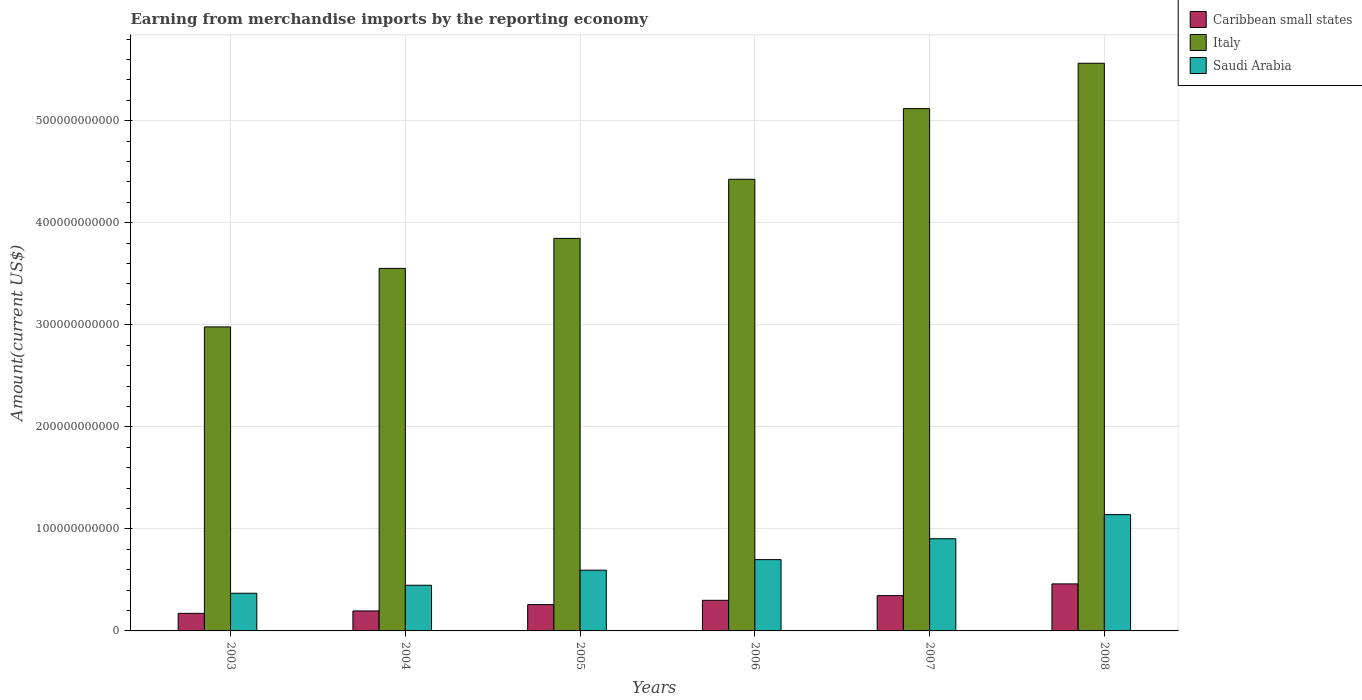How many different coloured bars are there?
Ensure brevity in your answer.  3. Are the number of bars per tick equal to the number of legend labels?
Make the answer very short. Yes. How many bars are there on the 1st tick from the right?
Your answer should be compact. 3. What is the amount earned from merchandise imports in Saudi Arabia in 2004?
Provide a short and direct response. 4.47e+1. Across all years, what is the maximum amount earned from merchandise imports in Caribbean small states?
Provide a succinct answer. 4.61e+1. Across all years, what is the minimum amount earned from merchandise imports in Caribbean small states?
Provide a short and direct response. 1.72e+1. In which year was the amount earned from merchandise imports in Saudi Arabia maximum?
Offer a very short reply. 2008. In which year was the amount earned from merchandise imports in Italy minimum?
Give a very brief answer. 2003. What is the total amount earned from merchandise imports in Saudi Arabia in the graph?
Offer a terse response. 4.15e+11. What is the difference between the amount earned from merchandise imports in Caribbean small states in 2004 and that in 2007?
Your answer should be compact. -1.50e+1. What is the difference between the amount earned from merchandise imports in Saudi Arabia in 2007 and the amount earned from merchandise imports in Caribbean small states in 2006?
Your answer should be very brief. 6.04e+1. What is the average amount earned from merchandise imports in Saudi Arabia per year?
Offer a very short reply. 6.92e+1. In the year 2003, what is the difference between the amount earned from merchandise imports in Saudi Arabia and amount earned from merchandise imports in Italy?
Offer a very short reply. -2.61e+11. What is the ratio of the amount earned from merchandise imports in Caribbean small states in 2003 to that in 2008?
Ensure brevity in your answer.  0.37. What is the difference between the highest and the second highest amount earned from merchandise imports in Italy?
Your answer should be compact. 4.44e+1. What is the difference between the highest and the lowest amount earned from merchandise imports in Saudi Arabia?
Your answer should be very brief. 7.70e+1. What does the 3rd bar from the left in 2008 represents?
Offer a very short reply. Saudi Arabia. What does the 1st bar from the right in 2006 represents?
Your answer should be compact. Saudi Arabia. How many bars are there?
Your response must be concise. 18. Are all the bars in the graph horizontal?
Your response must be concise. No. What is the difference between two consecutive major ticks on the Y-axis?
Provide a short and direct response. 1.00e+11. Does the graph contain grids?
Keep it short and to the point. Yes. Where does the legend appear in the graph?
Offer a very short reply. Top right. How are the legend labels stacked?
Your response must be concise. Vertical. What is the title of the graph?
Your answer should be very brief. Earning from merchandise imports by the reporting economy. Does "Bolivia" appear as one of the legend labels in the graph?
Provide a short and direct response. No. What is the label or title of the Y-axis?
Ensure brevity in your answer.  Amount(current US$). What is the Amount(current US$) of Caribbean small states in 2003?
Your answer should be compact. 1.72e+1. What is the Amount(current US$) of Italy in 2003?
Your answer should be very brief. 2.98e+11. What is the Amount(current US$) of Saudi Arabia in 2003?
Your response must be concise. 3.69e+1. What is the Amount(current US$) of Caribbean small states in 2004?
Offer a very short reply. 1.96e+1. What is the Amount(current US$) of Italy in 2004?
Your answer should be compact. 3.55e+11. What is the Amount(current US$) in Saudi Arabia in 2004?
Provide a succinct answer. 4.47e+1. What is the Amount(current US$) of Caribbean small states in 2005?
Your response must be concise. 2.58e+1. What is the Amount(current US$) of Italy in 2005?
Make the answer very short. 3.85e+11. What is the Amount(current US$) in Saudi Arabia in 2005?
Give a very brief answer. 5.95e+1. What is the Amount(current US$) of Caribbean small states in 2006?
Your answer should be compact. 3.00e+1. What is the Amount(current US$) in Italy in 2006?
Provide a succinct answer. 4.43e+11. What is the Amount(current US$) of Saudi Arabia in 2006?
Offer a terse response. 6.99e+1. What is the Amount(current US$) of Caribbean small states in 2007?
Provide a short and direct response. 3.46e+1. What is the Amount(current US$) in Italy in 2007?
Your answer should be compact. 5.12e+11. What is the Amount(current US$) of Saudi Arabia in 2007?
Your answer should be compact. 9.04e+1. What is the Amount(current US$) of Caribbean small states in 2008?
Provide a short and direct response. 4.61e+1. What is the Amount(current US$) in Italy in 2008?
Give a very brief answer. 5.56e+11. What is the Amount(current US$) in Saudi Arabia in 2008?
Ensure brevity in your answer.  1.14e+11. Across all years, what is the maximum Amount(current US$) in Caribbean small states?
Offer a terse response. 4.61e+1. Across all years, what is the maximum Amount(current US$) in Italy?
Your response must be concise. 5.56e+11. Across all years, what is the maximum Amount(current US$) of Saudi Arabia?
Ensure brevity in your answer.  1.14e+11. Across all years, what is the minimum Amount(current US$) of Caribbean small states?
Your answer should be compact. 1.72e+1. Across all years, what is the minimum Amount(current US$) of Italy?
Keep it short and to the point. 2.98e+11. Across all years, what is the minimum Amount(current US$) in Saudi Arabia?
Offer a very short reply. 3.69e+1. What is the total Amount(current US$) of Caribbean small states in the graph?
Give a very brief answer. 1.73e+11. What is the total Amount(current US$) of Italy in the graph?
Provide a short and direct response. 2.55e+12. What is the total Amount(current US$) in Saudi Arabia in the graph?
Give a very brief answer. 4.15e+11. What is the difference between the Amount(current US$) of Caribbean small states in 2003 and that in 2004?
Your answer should be compact. -2.38e+09. What is the difference between the Amount(current US$) of Italy in 2003 and that in 2004?
Provide a short and direct response. -5.74e+1. What is the difference between the Amount(current US$) in Saudi Arabia in 2003 and that in 2004?
Your answer should be compact. -7.83e+09. What is the difference between the Amount(current US$) in Caribbean small states in 2003 and that in 2005?
Your response must be concise. -8.58e+09. What is the difference between the Amount(current US$) in Italy in 2003 and that in 2005?
Provide a succinct answer. -8.68e+1. What is the difference between the Amount(current US$) in Saudi Arabia in 2003 and that in 2005?
Provide a short and direct response. -2.26e+1. What is the difference between the Amount(current US$) in Caribbean small states in 2003 and that in 2006?
Offer a very short reply. -1.28e+1. What is the difference between the Amount(current US$) of Italy in 2003 and that in 2006?
Ensure brevity in your answer.  -1.45e+11. What is the difference between the Amount(current US$) of Saudi Arabia in 2003 and that in 2006?
Offer a terse response. -3.30e+1. What is the difference between the Amount(current US$) in Caribbean small states in 2003 and that in 2007?
Make the answer very short. -1.74e+1. What is the difference between the Amount(current US$) in Italy in 2003 and that in 2007?
Your answer should be very brief. -2.14e+11. What is the difference between the Amount(current US$) of Saudi Arabia in 2003 and that in 2007?
Offer a very short reply. -5.34e+1. What is the difference between the Amount(current US$) in Caribbean small states in 2003 and that in 2008?
Make the answer very short. -2.89e+1. What is the difference between the Amount(current US$) of Italy in 2003 and that in 2008?
Your answer should be very brief. -2.58e+11. What is the difference between the Amount(current US$) in Saudi Arabia in 2003 and that in 2008?
Your answer should be very brief. -7.70e+1. What is the difference between the Amount(current US$) in Caribbean small states in 2004 and that in 2005?
Provide a short and direct response. -6.20e+09. What is the difference between the Amount(current US$) of Italy in 2004 and that in 2005?
Your response must be concise. -2.94e+1. What is the difference between the Amount(current US$) in Saudi Arabia in 2004 and that in 2005?
Provide a short and direct response. -1.48e+1. What is the difference between the Amount(current US$) in Caribbean small states in 2004 and that in 2006?
Offer a very short reply. -1.04e+1. What is the difference between the Amount(current US$) in Italy in 2004 and that in 2006?
Make the answer very short. -8.73e+1. What is the difference between the Amount(current US$) of Saudi Arabia in 2004 and that in 2006?
Make the answer very short. -2.51e+1. What is the difference between the Amount(current US$) in Caribbean small states in 2004 and that in 2007?
Make the answer very short. -1.50e+1. What is the difference between the Amount(current US$) of Italy in 2004 and that in 2007?
Your answer should be compact. -1.57e+11. What is the difference between the Amount(current US$) in Saudi Arabia in 2004 and that in 2007?
Provide a succinct answer. -4.56e+1. What is the difference between the Amount(current US$) in Caribbean small states in 2004 and that in 2008?
Your answer should be very brief. -2.65e+1. What is the difference between the Amount(current US$) of Italy in 2004 and that in 2008?
Ensure brevity in your answer.  -2.01e+11. What is the difference between the Amount(current US$) of Saudi Arabia in 2004 and that in 2008?
Your response must be concise. -6.92e+1. What is the difference between the Amount(current US$) in Caribbean small states in 2005 and that in 2006?
Offer a very short reply. -4.20e+09. What is the difference between the Amount(current US$) in Italy in 2005 and that in 2006?
Ensure brevity in your answer.  -5.79e+1. What is the difference between the Amount(current US$) in Saudi Arabia in 2005 and that in 2006?
Give a very brief answer. -1.04e+1. What is the difference between the Amount(current US$) of Caribbean small states in 2005 and that in 2007?
Make the answer very short. -8.80e+09. What is the difference between the Amount(current US$) in Italy in 2005 and that in 2007?
Keep it short and to the point. -1.27e+11. What is the difference between the Amount(current US$) of Saudi Arabia in 2005 and that in 2007?
Provide a succinct answer. -3.08e+1. What is the difference between the Amount(current US$) of Caribbean small states in 2005 and that in 2008?
Provide a short and direct response. -2.03e+1. What is the difference between the Amount(current US$) in Italy in 2005 and that in 2008?
Your answer should be compact. -1.72e+11. What is the difference between the Amount(current US$) of Saudi Arabia in 2005 and that in 2008?
Ensure brevity in your answer.  -5.44e+1. What is the difference between the Amount(current US$) in Caribbean small states in 2006 and that in 2007?
Your answer should be compact. -4.60e+09. What is the difference between the Amount(current US$) of Italy in 2006 and that in 2007?
Offer a terse response. -6.93e+1. What is the difference between the Amount(current US$) of Saudi Arabia in 2006 and that in 2007?
Offer a terse response. -2.05e+1. What is the difference between the Amount(current US$) of Caribbean small states in 2006 and that in 2008?
Offer a very short reply. -1.61e+1. What is the difference between the Amount(current US$) in Italy in 2006 and that in 2008?
Keep it short and to the point. -1.14e+11. What is the difference between the Amount(current US$) in Saudi Arabia in 2006 and that in 2008?
Make the answer very short. -4.41e+1. What is the difference between the Amount(current US$) of Caribbean small states in 2007 and that in 2008?
Keep it short and to the point. -1.15e+1. What is the difference between the Amount(current US$) of Italy in 2007 and that in 2008?
Provide a short and direct response. -4.44e+1. What is the difference between the Amount(current US$) in Saudi Arabia in 2007 and that in 2008?
Your answer should be compact. -2.36e+1. What is the difference between the Amount(current US$) of Caribbean small states in 2003 and the Amount(current US$) of Italy in 2004?
Keep it short and to the point. -3.38e+11. What is the difference between the Amount(current US$) of Caribbean small states in 2003 and the Amount(current US$) of Saudi Arabia in 2004?
Provide a succinct answer. -2.75e+1. What is the difference between the Amount(current US$) in Italy in 2003 and the Amount(current US$) in Saudi Arabia in 2004?
Offer a very short reply. 2.53e+11. What is the difference between the Amount(current US$) of Caribbean small states in 2003 and the Amount(current US$) of Italy in 2005?
Provide a succinct answer. -3.67e+11. What is the difference between the Amount(current US$) in Caribbean small states in 2003 and the Amount(current US$) in Saudi Arabia in 2005?
Ensure brevity in your answer.  -4.23e+1. What is the difference between the Amount(current US$) in Italy in 2003 and the Amount(current US$) in Saudi Arabia in 2005?
Your answer should be very brief. 2.38e+11. What is the difference between the Amount(current US$) in Caribbean small states in 2003 and the Amount(current US$) in Italy in 2006?
Your response must be concise. -4.25e+11. What is the difference between the Amount(current US$) of Caribbean small states in 2003 and the Amount(current US$) of Saudi Arabia in 2006?
Provide a short and direct response. -5.27e+1. What is the difference between the Amount(current US$) in Italy in 2003 and the Amount(current US$) in Saudi Arabia in 2006?
Ensure brevity in your answer.  2.28e+11. What is the difference between the Amount(current US$) in Caribbean small states in 2003 and the Amount(current US$) in Italy in 2007?
Make the answer very short. -4.95e+11. What is the difference between the Amount(current US$) of Caribbean small states in 2003 and the Amount(current US$) of Saudi Arabia in 2007?
Provide a short and direct response. -7.31e+1. What is the difference between the Amount(current US$) of Italy in 2003 and the Amount(current US$) of Saudi Arabia in 2007?
Your answer should be compact. 2.08e+11. What is the difference between the Amount(current US$) in Caribbean small states in 2003 and the Amount(current US$) in Italy in 2008?
Your answer should be very brief. -5.39e+11. What is the difference between the Amount(current US$) of Caribbean small states in 2003 and the Amount(current US$) of Saudi Arabia in 2008?
Provide a short and direct response. -9.67e+1. What is the difference between the Amount(current US$) of Italy in 2003 and the Amount(current US$) of Saudi Arabia in 2008?
Ensure brevity in your answer.  1.84e+11. What is the difference between the Amount(current US$) of Caribbean small states in 2004 and the Amount(current US$) of Italy in 2005?
Offer a very short reply. -3.65e+11. What is the difference between the Amount(current US$) of Caribbean small states in 2004 and the Amount(current US$) of Saudi Arabia in 2005?
Make the answer very short. -3.99e+1. What is the difference between the Amount(current US$) of Italy in 2004 and the Amount(current US$) of Saudi Arabia in 2005?
Provide a succinct answer. 2.96e+11. What is the difference between the Amount(current US$) in Caribbean small states in 2004 and the Amount(current US$) in Italy in 2006?
Give a very brief answer. -4.23e+11. What is the difference between the Amount(current US$) of Caribbean small states in 2004 and the Amount(current US$) of Saudi Arabia in 2006?
Keep it short and to the point. -5.03e+1. What is the difference between the Amount(current US$) in Italy in 2004 and the Amount(current US$) in Saudi Arabia in 2006?
Provide a short and direct response. 2.85e+11. What is the difference between the Amount(current US$) of Caribbean small states in 2004 and the Amount(current US$) of Italy in 2007?
Give a very brief answer. -4.92e+11. What is the difference between the Amount(current US$) in Caribbean small states in 2004 and the Amount(current US$) in Saudi Arabia in 2007?
Make the answer very short. -7.08e+1. What is the difference between the Amount(current US$) in Italy in 2004 and the Amount(current US$) in Saudi Arabia in 2007?
Keep it short and to the point. 2.65e+11. What is the difference between the Amount(current US$) of Caribbean small states in 2004 and the Amount(current US$) of Italy in 2008?
Offer a terse response. -5.37e+11. What is the difference between the Amount(current US$) in Caribbean small states in 2004 and the Amount(current US$) in Saudi Arabia in 2008?
Your answer should be very brief. -9.44e+1. What is the difference between the Amount(current US$) of Italy in 2004 and the Amount(current US$) of Saudi Arabia in 2008?
Ensure brevity in your answer.  2.41e+11. What is the difference between the Amount(current US$) in Caribbean small states in 2005 and the Amount(current US$) in Italy in 2006?
Provide a short and direct response. -4.17e+11. What is the difference between the Amount(current US$) in Caribbean small states in 2005 and the Amount(current US$) in Saudi Arabia in 2006?
Make the answer very short. -4.41e+1. What is the difference between the Amount(current US$) in Italy in 2005 and the Amount(current US$) in Saudi Arabia in 2006?
Provide a short and direct response. 3.15e+11. What is the difference between the Amount(current US$) of Caribbean small states in 2005 and the Amount(current US$) of Italy in 2007?
Provide a short and direct response. -4.86e+11. What is the difference between the Amount(current US$) of Caribbean small states in 2005 and the Amount(current US$) of Saudi Arabia in 2007?
Ensure brevity in your answer.  -6.46e+1. What is the difference between the Amount(current US$) in Italy in 2005 and the Amount(current US$) in Saudi Arabia in 2007?
Ensure brevity in your answer.  2.94e+11. What is the difference between the Amount(current US$) in Caribbean small states in 2005 and the Amount(current US$) in Italy in 2008?
Offer a terse response. -5.31e+11. What is the difference between the Amount(current US$) in Caribbean small states in 2005 and the Amount(current US$) in Saudi Arabia in 2008?
Offer a very short reply. -8.82e+1. What is the difference between the Amount(current US$) in Italy in 2005 and the Amount(current US$) in Saudi Arabia in 2008?
Offer a very short reply. 2.71e+11. What is the difference between the Amount(current US$) of Caribbean small states in 2006 and the Amount(current US$) of Italy in 2007?
Offer a terse response. -4.82e+11. What is the difference between the Amount(current US$) of Caribbean small states in 2006 and the Amount(current US$) of Saudi Arabia in 2007?
Your answer should be very brief. -6.04e+1. What is the difference between the Amount(current US$) of Italy in 2006 and the Amount(current US$) of Saudi Arabia in 2007?
Offer a very short reply. 3.52e+11. What is the difference between the Amount(current US$) in Caribbean small states in 2006 and the Amount(current US$) in Italy in 2008?
Provide a short and direct response. -5.26e+11. What is the difference between the Amount(current US$) of Caribbean small states in 2006 and the Amount(current US$) of Saudi Arabia in 2008?
Give a very brief answer. -8.40e+1. What is the difference between the Amount(current US$) of Italy in 2006 and the Amount(current US$) of Saudi Arabia in 2008?
Make the answer very short. 3.29e+11. What is the difference between the Amount(current US$) of Caribbean small states in 2007 and the Amount(current US$) of Italy in 2008?
Provide a short and direct response. -5.22e+11. What is the difference between the Amount(current US$) in Caribbean small states in 2007 and the Amount(current US$) in Saudi Arabia in 2008?
Ensure brevity in your answer.  -7.93e+1. What is the difference between the Amount(current US$) of Italy in 2007 and the Amount(current US$) of Saudi Arabia in 2008?
Provide a succinct answer. 3.98e+11. What is the average Amount(current US$) of Caribbean small states per year?
Your answer should be compact. 2.89e+1. What is the average Amount(current US$) of Italy per year?
Give a very brief answer. 4.25e+11. What is the average Amount(current US$) in Saudi Arabia per year?
Give a very brief answer. 6.92e+1. In the year 2003, what is the difference between the Amount(current US$) of Caribbean small states and Amount(current US$) of Italy?
Keep it short and to the point. -2.81e+11. In the year 2003, what is the difference between the Amount(current US$) in Caribbean small states and Amount(current US$) in Saudi Arabia?
Provide a succinct answer. -1.97e+1. In the year 2003, what is the difference between the Amount(current US$) of Italy and Amount(current US$) of Saudi Arabia?
Give a very brief answer. 2.61e+11. In the year 2004, what is the difference between the Amount(current US$) in Caribbean small states and Amount(current US$) in Italy?
Ensure brevity in your answer.  -3.36e+11. In the year 2004, what is the difference between the Amount(current US$) in Caribbean small states and Amount(current US$) in Saudi Arabia?
Keep it short and to the point. -2.52e+1. In the year 2004, what is the difference between the Amount(current US$) in Italy and Amount(current US$) in Saudi Arabia?
Keep it short and to the point. 3.11e+11. In the year 2005, what is the difference between the Amount(current US$) of Caribbean small states and Amount(current US$) of Italy?
Provide a succinct answer. -3.59e+11. In the year 2005, what is the difference between the Amount(current US$) in Caribbean small states and Amount(current US$) in Saudi Arabia?
Your response must be concise. -3.37e+1. In the year 2005, what is the difference between the Amount(current US$) of Italy and Amount(current US$) of Saudi Arabia?
Ensure brevity in your answer.  3.25e+11. In the year 2006, what is the difference between the Amount(current US$) in Caribbean small states and Amount(current US$) in Italy?
Provide a succinct answer. -4.13e+11. In the year 2006, what is the difference between the Amount(current US$) of Caribbean small states and Amount(current US$) of Saudi Arabia?
Make the answer very short. -3.99e+1. In the year 2006, what is the difference between the Amount(current US$) in Italy and Amount(current US$) in Saudi Arabia?
Your answer should be very brief. 3.73e+11. In the year 2007, what is the difference between the Amount(current US$) of Caribbean small states and Amount(current US$) of Italy?
Ensure brevity in your answer.  -4.77e+11. In the year 2007, what is the difference between the Amount(current US$) of Caribbean small states and Amount(current US$) of Saudi Arabia?
Provide a short and direct response. -5.58e+1. In the year 2007, what is the difference between the Amount(current US$) in Italy and Amount(current US$) in Saudi Arabia?
Provide a succinct answer. 4.22e+11. In the year 2008, what is the difference between the Amount(current US$) in Caribbean small states and Amount(current US$) in Italy?
Provide a short and direct response. -5.10e+11. In the year 2008, what is the difference between the Amount(current US$) in Caribbean small states and Amount(current US$) in Saudi Arabia?
Make the answer very short. -6.79e+1. In the year 2008, what is the difference between the Amount(current US$) in Italy and Amount(current US$) in Saudi Arabia?
Provide a short and direct response. 4.42e+11. What is the ratio of the Amount(current US$) of Caribbean small states in 2003 to that in 2004?
Your answer should be compact. 0.88. What is the ratio of the Amount(current US$) in Italy in 2003 to that in 2004?
Your answer should be compact. 0.84. What is the ratio of the Amount(current US$) of Saudi Arabia in 2003 to that in 2004?
Give a very brief answer. 0.82. What is the ratio of the Amount(current US$) in Caribbean small states in 2003 to that in 2005?
Your answer should be compact. 0.67. What is the ratio of the Amount(current US$) in Italy in 2003 to that in 2005?
Offer a very short reply. 0.77. What is the ratio of the Amount(current US$) of Saudi Arabia in 2003 to that in 2005?
Keep it short and to the point. 0.62. What is the ratio of the Amount(current US$) of Caribbean small states in 2003 to that in 2006?
Give a very brief answer. 0.57. What is the ratio of the Amount(current US$) in Italy in 2003 to that in 2006?
Your answer should be very brief. 0.67. What is the ratio of the Amount(current US$) in Saudi Arabia in 2003 to that in 2006?
Your response must be concise. 0.53. What is the ratio of the Amount(current US$) in Caribbean small states in 2003 to that in 2007?
Ensure brevity in your answer.  0.5. What is the ratio of the Amount(current US$) of Italy in 2003 to that in 2007?
Your answer should be compact. 0.58. What is the ratio of the Amount(current US$) of Saudi Arabia in 2003 to that in 2007?
Your answer should be compact. 0.41. What is the ratio of the Amount(current US$) of Caribbean small states in 2003 to that in 2008?
Your answer should be very brief. 0.37. What is the ratio of the Amount(current US$) of Italy in 2003 to that in 2008?
Ensure brevity in your answer.  0.54. What is the ratio of the Amount(current US$) in Saudi Arabia in 2003 to that in 2008?
Give a very brief answer. 0.32. What is the ratio of the Amount(current US$) in Caribbean small states in 2004 to that in 2005?
Offer a terse response. 0.76. What is the ratio of the Amount(current US$) of Italy in 2004 to that in 2005?
Offer a very short reply. 0.92. What is the ratio of the Amount(current US$) of Saudi Arabia in 2004 to that in 2005?
Keep it short and to the point. 0.75. What is the ratio of the Amount(current US$) in Caribbean small states in 2004 to that in 2006?
Make the answer very short. 0.65. What is the ratio of the Amount(current US$) of Italy in 2004 to that in 2006?
Give a very brief answer. 0.8. What is the ratio of the Amount(current US$) in Saudi Arabia in 2004 to that in 2006?
Provide a succinct answer. 0.64. What is the ratio of the Amount(current US$) in Caribbean small states in 2004 to that in 2007?
Your response must be concise. 0.57. What is the ratio of the Amount(current US$) in Italy in 2004 to that in 2007?
Provide a short and direct response. 0.69. What is the ratio of the Amount(current US$) of Saudi Arabia in 2004 to that in 2007?
Provide a short and direct response. 0.5. What is the ratio of the Amount(current US$) of Caribbean small states in 2004 to that in 2008?
Keep it short and to the point. 0.43. What is the ratio of the Amount(current US$) of Italy in 2004 to that in 2008?
Ensure brevity in your answer.  0.64. What is the ratio of the Amount(current US$) in Saudi Arabia in 2004 to that in 2008?
Your answer should be compact. 0.39. What is the ratio of the Amount(current US$) of Caribbean small states in 2005 to that in 2006?
Keep it short and to the point. 0.86. What is the ratio of the Amount(current US$) in Italy in 2005 to that in 2006?
Your answer should be compact. 0.87. What is the ratio of the Amount(current US$) of Saudi Arabia in 2005 to that in 2006?
Your answer should be very brief. 0.85. What is the ratio of the Amount(current US$) of Caribbean small states in 2005 to that in 2007?
Offer a terse response. 0.75. What is the ratio of the Amount(current US$) in Italy in 2005 to that in 2007?
Your answer should be very brief. 0.75. What is the ratio of the Amount(current US$) in Saudi Arabia in 2005 to that in 2007?
Your response must be concise. 0.66. What is the ratio of the Amount(current US$) of Caribbean small states in 2005 to that in 2008?
Give a very brief answer. 0.56. What is the ratio of the Amount(current US$) of Italy in 2005 to that in 2008?
Offer a very short reply. 0.69. What is the ratio of the Amount(current US$) in Saudi Arabia in 2005 to that in 2008?
Make the answer very short. 0.52. What is the ratio of the Amount(current US$) of Caribbean small states in 2006 to that in 2007?
Offer a terse response. 0.87. What is the ratio of the Amount(current US$) in Italy in 2006 to that in 2007?
Your response must be concise. 0.86. What is the ratio of the Amount(current US$) of Saudi Arabia in 2006 to that in 2007?
Give a very brief answer. 0.77. What is the ratio of the Amount(current US$) of Caribbean small states in 2006 to that in 2008?
Give a very brief answer. 0.65. What is the ratio of the Amount(current US$) in Italy in 2006 to that in 2008?
Provide a short and direct response. 0.8. What is the ratio of the Amount(current US$) of Saudi Arabia in 2006 to that in 2008?
Give a very brief answer. 0.61. What is the ratio of the Amount(current US$) of Caribbean small states in 2007 to that in 2008?
Your answer should be compact. 0.75. What is the ratio of the Amount(current US$) in Italy in 2007 to that in 2008?
Offer a terse response. 0.92. What is the ratio of the Amount(current US$) of Saudi Arabia in 2007 to that in 2008?
Provide a short and direct response. 0.79. What is the difference between the highest and the second highest Amount(current US$) of Caribbean small states?
Your answer should be compact. 1.15e+1. What is the difference between the highest and the second highest Amount(current US$) of Italy?
Provide a succinct answer. 4.44e+1. What is the difference between the highest and the second highest Amount(current US$) of Saudi Arabia?
Offer a very short reply. 2.36e+1. What is the difference between the highest and the lowest Amount(current US$) in Caribbean small states?
Your answer should be compact. 2.89e+1. What is the difference between the highest and the lowest Amount(current US$) of Italy?
Your response must be concise. 2.58e+11. What is the difference between the highest and the lowest Amount(current US$) of Saudi Arabia?
Your response must be concise. 7.70e+1. 